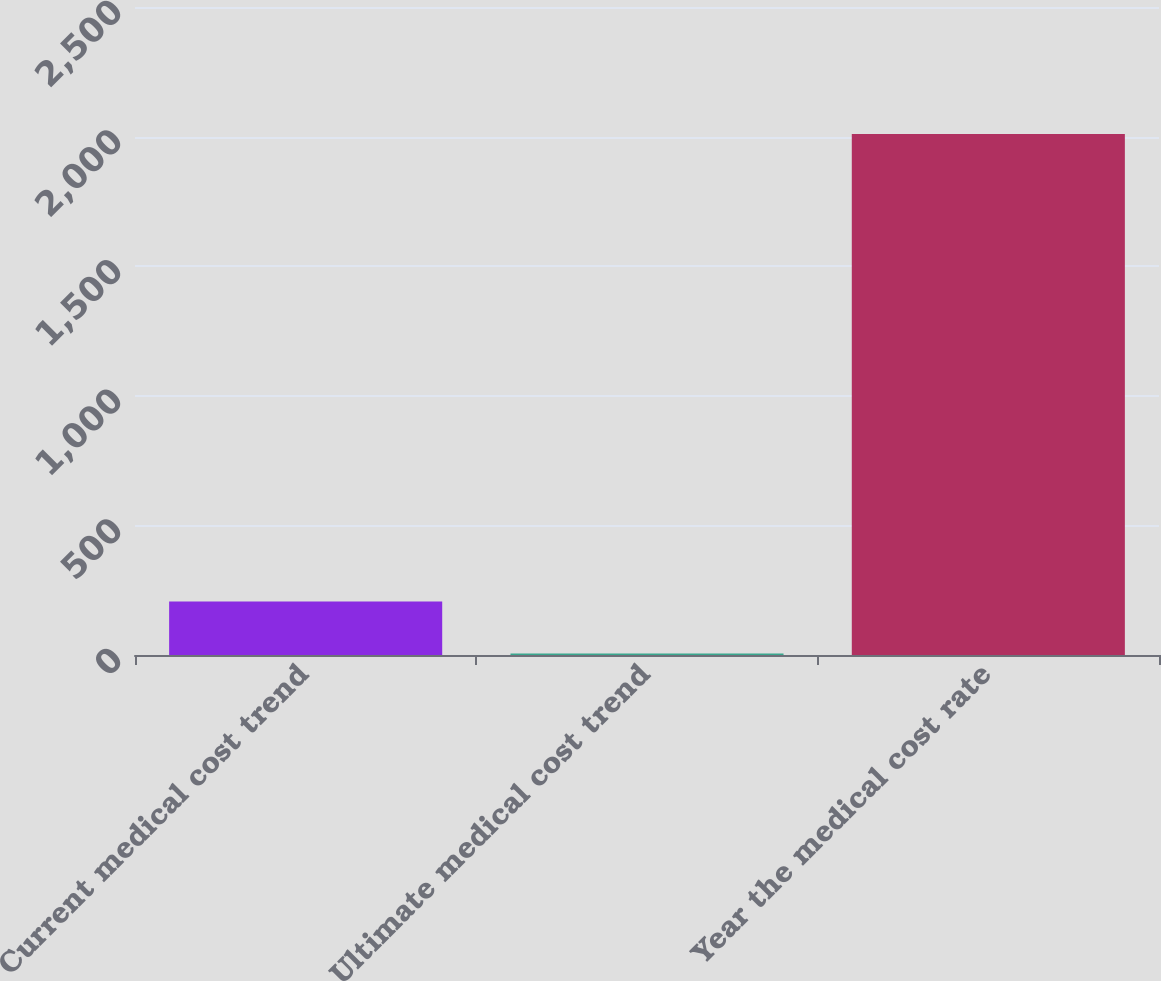Convert chart to OTSL. <chart><loc_0><loc_0><loc_500><loc_500><bar_chart><fcel>Current medical cost trend<fcel>Ultimate medical cost trend<fcel>Year the medical cost rate<nl><fcel>205.95<fcel>5.5<fcel>2010<nl></chart> 